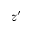Convert formula to latex. <formula><loc_0><loc_0><loc_500><loc_500>z ^ { \prime }</formula> 